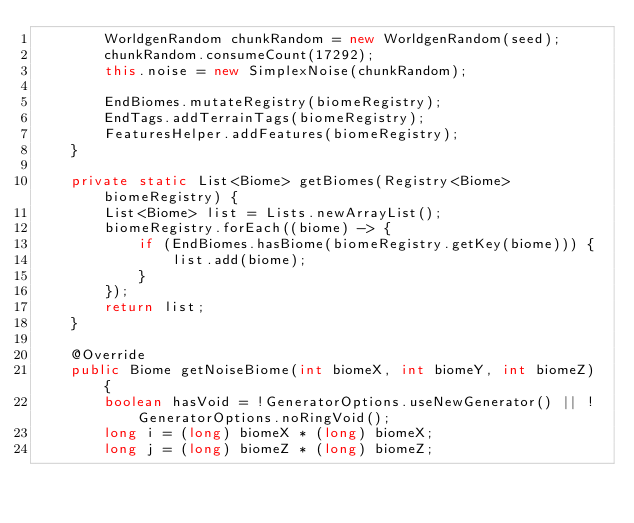<code> <loc_0><loc_0><loc_500><loc_500><_Java_>		WorldgenRandom chunkRandom = new WorldgenRandom(seed);
		chunkRandom.consumeCount(17292);
		this.noise = new SimplexNoise(chunkRandom);

		EndBiomes.mutateRegistry(biomeRegistry);
		EndTags.addTerrainTags(biomeRegistry);
		FeaturesHelper.addFeatures(biomeRegistry);
	}
	
	private static List<Biome> getBiomes(Registry<Biome> biomeRegistry) {
		List<Biome> list = Lists.newArrayList();
		biomeRegistry.forEach((biome) -> {
			if (EndBiomes.hasBiome(biomeRegistry.getKey(biome))) {
				list.add(biome);
			}
		});
		return list;
	}

	@Override
	public Biome getNoiseBiome(int biomeX, int biomeY, int biomeZ) {
		boolean hasVoid = !GeneratorOptions.useNewGenerator() || !GeneratorOptions.noRingVoid();
		long i = (long) biomeX * (long) biomeX;
		long j = (long) biomeZ * (long) biomeZ;
		</code> 